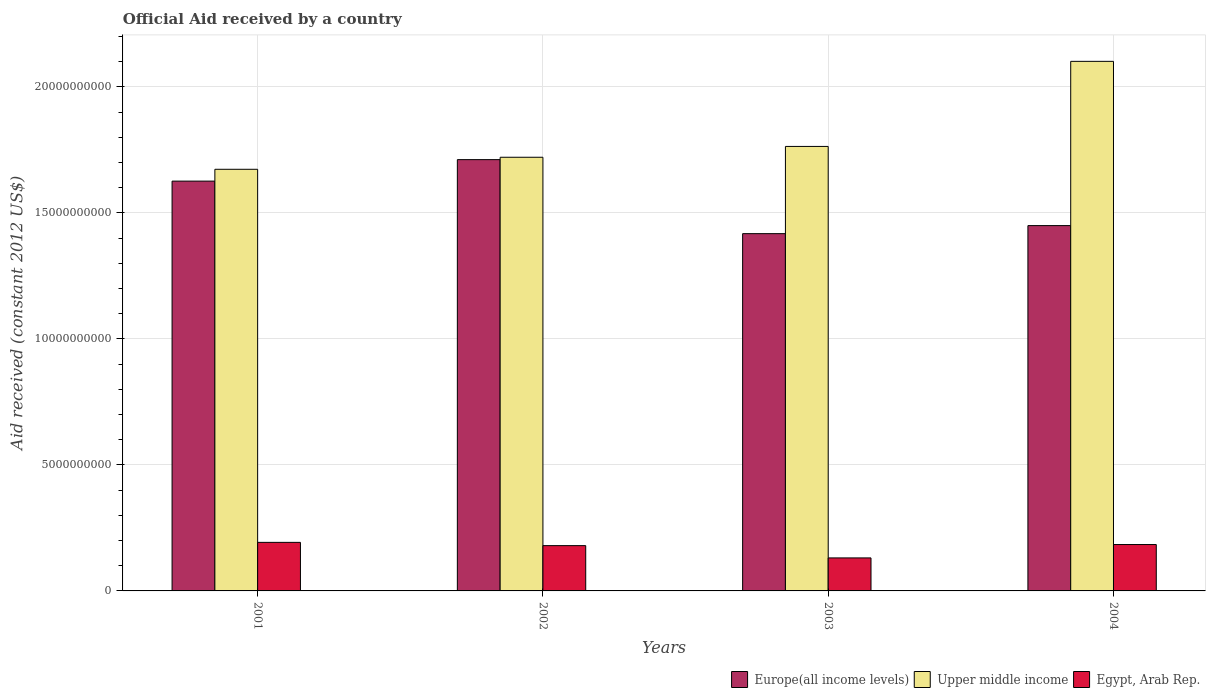How many different coloured bars are there?
Your answer should be compact. 3. Are the number of bars on each tick of the X-axis equal?
Provide a succinct answer. Yes. How many bars are there on the 4th tick from the right?
Your response must be concise. 3. What is the label of the 2nd group of bars from the left?
Make the answer very short. 2002. What is the net official aid received in Europe(all income levels) in 2003?
Make the answer very short. 1.42e+1. Across all years, what is the maximum net official aid received in Europe(all income levels)?
Offer a very short reply. 1.71e+1. Across all years, what is the minimum net official aid received in Egypt, Arab Rep.?
Make the answer very short. 1.31e+09. In which year was the net official aid received in Europe(all income levels) maximum?
Your response must be concise. 2002. What is the total net official aid received in Egypt, Arab Rep. in the graph?
Give a very brief answer. 6.87e+09. What is the difference between the net official aid received in Upper middle income in 2001 and that in 2004?
Provide a succinct answer. -4.28e+09. What is the difference between the net official aid received in Upper middle income in 2003 and the net official aid received in Egypt, Arab Rep. in 2002?
Make the answer very short. 1.58e+1. What is the average net official aid received in Egypt, Arab Rep. per year?
Offer a very short reply. 1.72e+09. In the year 2001, what is the difference between the net official aid received in Europe(all income levels) and net official aid received in Upper middle income?
Your response must be concise. -4.69e+08. In how many years, is the net official aid received in Upper middle income greater than 17000000000 US$?
Your answer should be very brief. 3. What is the ratio of the net official aid received in Upper middle income in 2001 to that in 2004?
Your answer should be compact. 0.8. Is the difference between the net official aid received in Europe(all income levels) in 2001 and 2004 greater than the difference between the net official aid received in Upper middle income in 2001 and 2004?
Make the answer very short. Yes. What is the difference between the highest and the second highest net official aid received in Europe(all income levels)?
Your response must be concise. 8.52e+08. What is the difference between the highest and the lowest net official aid received in Europe(all income levels)?
Offer a terse response. 2.94e+09. In how many years, is the net official aid received in Egypt, Arab Rep. greater than the average net official aid received in Egypt, Arab Rep. taken over all years?
Ensure brevity in your answer.  3. Is the sum of the net official aid received in Egypt, Arab Rep. in 2002 and 2003 greater than the maximum net official aid received in Upper middle income across all years?
Keep it short and to the point. No. What does the 2nd bar from the left in 2001 represents?
Your answer should be very brief. Upper middle income. What does the 2nd bar from the right in 2002 represents?
Your answer should be compact. Upper middle income. How many bars are there?
Your answer should be compact. 12. How many years are there in the graph?
Offer a very short reply. 4. What is the difference between two consecutive major ticks on the Y-axis?
Make the answer very short. 5.00e+09. Does the graph contain any zero values?
Your answer should be very brief. No. Where does the legend appear in the graph?
Ensure brevity in your answer.  Bottom right. How many legend labels are there?
Your answer should be compact. 3. How are the legend labels stacked?
Your answer should be very brief. Horizontal. What is the title of the graph?
Make the answer very short. Official Aid received by a country. Does "South Africa" appear as one of the legend labels in the graph?
Give a very brief answer. No. What is the label or title of the X-axis?
Ensure brevity in your answer.  Years. What is the label or title of the Y-axis?
Offer a terse response. Aid received (constant 2012 US$). What is the Aid received (constant 2012 US$) of Europe(all income levels) in 2001?
Your answer should be very brief. 1.63e+1. What is the Aid received (constant 2012 US$) of Upper middle income in 2001?
Offer a very short reply. 1.67e+1. What is the Aid received (constant 2012 US$) in Egypt, Arab Rep. in 2001?
Your response must be concise. 1.93e+09. What is the Aid received (constant 2012 US$) in Europe(all income levels) in 2002?
Ensure brevity in your answer.  1.71e+1. What is the Aid received (constant 2012 US$) in Upper middle income in 2002?
Provide a succinct answer. 1.72e+1. What is the Aid received (constant 2012 US$) in Egypt, Arab Rep. in 2002?
Your answer should be compact. 1.80e+09. What is the Aid received (constant 2012 US$) in Europe(all income levels) in 2003?
Give a very brief answer. 1.42e+1. What is the Aid received (constant 2012 US$) in Upper middle income in 2003?
Your answer should be compact. 1.76e+1. What is the Aid received (constant 2012 US$) of Egypt, Arab Rep. in 2003?
Your answer should be very brief. 1.31e+09. What is the Aid received (constant 2012 US$) of Europe(all income levels) in 2004?
Your answer should be very brief. 1.45e+1. What is the Aid received (constant 2012 US$) in Upper middle income in 2004?
Keep it short and to the point. 2.10e+1. What is the Aid received (constant 2012 US$) in Egypt, Arab Rep. in 2004?
Your answer should be very brief. 1.84e+09. Across all years, what is the maximum Aid received (constant 2012 US$) in Europe(all income levels)?
Offer a very short reply. 1.71e+1. Across all years, what is the maximum Aid received (constant 2012 US$) of Upper middle income?
Your response must be concise. 2.10e+1. Across all years, what is the maximum Aid received (constant 2012 US$) in Egypt, Arab Rep.?
Offer a terse response. 1.93e+09. Across all years, what is the minimum Aid received (constant 2012 US$) of Europe(all income levels)?
Your response must be concise. 1.42e+1. Across all years, what is the minimum Aid received (constant 2012 US$) in Upper middle income?
Offer a very short reply. 1.67e+1. Across all years, what is the minimum Aid received (constant 2012 US$) of Egypt, Arab Rep.?
Your response must be concise. 1.31e+09. What is the total Aid received (constant 2012 US$) in Europe(all income levels) in the graph?
Your answer should be very brief. 6.21e+1. What is the total Aid received (constant 2012 US$) in Upper middle income in the graph?
Give a very brief answer. 7.26e+1. What is the total Aid received (constant 2012 US$) of Egypt, Arab Rep. in the graph?
Make the answer very short. 6.87e+09. What is the difference between the Aid received (constant 2012 US$) in Europe(all income levels) in 2001 and that in 2002?
Offer a terse response. -8.52e+08. What is the difference between the Aid received (constant 2012 US$) in Upper middle income in 2001 and that in 2002?
Provide a short and direct response. -4.77e+08. What is the difference between the Aid received (constant 2012 US$) of Egypt, Arab Rep. in 2001 and that in 2002?
Make the answer very short. 1.29e+08. What is the difference between the Aid received (constant 2012 US$) in Europe(all income levels) in 2001 and that in 2003?
Your answer should be compact. 2.08e+09. What is the difference between the Aid received (constant 2012 US$) of Upper middle income in 2001 and that in 2003?
Your answer should be compact. -9.07e+08. What is the difference between the Aid received (constant 2012 US$) in Egypt, Arab Rep. in 2001 and that in 2003?
Keep it short and to the point. 6.17e+08. What is the difference between the Aid received (constant 2012 US$) in Europe(all income levels) in 2001 and that in 2004?
Offer a very short reply. 1.77e+09. What is the difference between the Aid received (constant 2012 US$) of Upper middle income in 2001 and that in 2004?
Your answer should be very brief. -4.28e+09. What is the difference between the Aid received (constant 2012 US$) in Egypt, Arab Rep. in 2001 and that in 2004?
Offer a very short reply. 8.60e+07. What is the difference between the Aid received (constant 2012 US$) in Europe(all income levels) in 2002 and that in 2003?
Your response must be concise. 2.94e+09. What is the difference between the Aid received (constant 2012 US$) of Upper middle income in 2002 and that in 2003?
Make the answer very short. -4.30e+08. What is the difference between the Aid received (constant 2012 US$) of Egypt, Arab Rep. in 2002 and that in 2003?
Offer a very short reply. 4.87e+08. What is the difference between the Aid received (constant 2012 US$) in Europe(all income levels) in 2002 and that in 2004?
Ensure brevity in your answer.  2.62e+09. What is the difference between the Aid received (constant 2012 US$) in Upper middle income in 2002 and that in 2004?
Ensure brevity in your answer.  -3.81e+09. What is the difference between the Aid received (constant 2012 US$) of Egypt, Arab Rep. in 2002 and that in 2004?
Ensure brevity in your answer.  -4.33e+07. What is the difference between the Aid received (constant 2012 US$) in Europe(all income levels) in 2003 and that in 2004?
Your answer should be very brief. -3.20e+08. What is the difference between the Aid received (constant 2012 US$) of Upper middle income in 2003 and that in 2004?
Offer a terse response. -3.38e+09. What is the difference between the Aid received (constant 2012 US$) of Egypt, Arab Rep. in 2003 and that in 2004?
Offer a terse response. -5.31e+08. What is the difference between the Aid received (constant 2012 US$) in Europe(all income levels) in 2001 and the Aid received (constant 2012 US$) in Upper middle income in 2002?
Make the answer very short. -9.46e+08. What is the difference between the Aid received (constant 2012 US$) of Europe(all income levels) in 2001 and the Aid received (constant 2012 US$) of Egypt, Arab Rep. in 2002?
Your answer should be compact. 1.45e+1. What is the difference between the Aid received (constant 2012 US$) in Upper middle income in 2001 and the Aid received (constant 2012 US$) in Egypt, Arab Rep. in 2002?
Your response must be concise. 1.49e+1. What is the difference between the Aid received (constant 2012 US$) in Europe(all income levels) in 2001 and the Aid received (constant 2012 US$) in Upper middle income in 2003?
Make the answer very short. -1.38e+09. What is the difference between the Aid received (constant 2012 US$) in Europe(all income levels) in 2001 and the Aid received (constant 2012 US$) in Egypt, Arab Rep. in 2003?
Keep it short and to the point. 1.50e+1. What is the difference between the Aid received (constant 2012 US$) in Upper middle income in 2001 and the Aid received (constant 2012 US$) in Egypt, Arab Rep. in 2003?
Your answer should be compact. 1.54e+1. What is the difference between the Aid received (constant 2012 US$) of Europe(all income levels) in 2001 and the Aid received (constant 2012 US$) of Upper middle income in 2004?
Keep it short and to the point. -4.75e+09. What is the difference between the Aid received (constant 2012 US$) in Europe(all income levels) in 2001 and the Aid received (constant 2012 US$) in Egypt, Arab Rep. in 2004?
Your answer should be very brief. 1.44e+1. What is the difference between the Aid received (constant 2012 US$) in Upper middle income in 2001 and the Aid received (constant 2012 US$) in Egypt, Arab Rep. in 2004?
Offer a terse response. 1.49e+1. What is the difference between the Aid received (constant 2012 US$) of Europe(all income levels) in 2002 and the Aid received (constant 2012 US$) of Upper middle income in 2003?
Your answer should be compact. -5.24e+08. What is the difference between the Aid received (constant 2012 US$) of Europe(all income levels) in 2002 and the Aid received (constant 2012 US$) of Egypt, Arab Rep. in 2003?
Ensure brevity in your answer.  1.58e+1. What is the difference between the Aid received (constant 2012 US$) in Upper middle income in 2002 and the Aid received (constant 2012 US$) in Egypt, Arab Rep. in 2003?
Give a very brief answer. 1.59e+1. What is the difference between the Aid received (constant 2012 US$) of Europe(all income levels) in 2002 and the Aid received (constant 2012 US$) of Upper middle income in 2004?
Give a very brief answer. -3.90e+09. What is the difference between the Aid received (constant 2012 US$) in Europe(all income levels) in 2002 and the Aid received (constant 2012 US$) in Egypt, Arab Rep. in 2004?
Provide a succinct answer. 1.53e+1. What is the difference between the Aid received (constant 2012 US$) in Upper middle income in 2002 and the Aid received (constant 2012 US$) in Egypt, Arab Rep. in 2004?
Offer a very short reply. 1.54e+1. What is the difference between the Aid received (constant 2012 US$) in Europe(all income levels) in 2003 and the Aid received (constant 2012 US$) in Upper middle income in 2004?
Make the answer very short. -6.84e+09. What is the difference between the Aid received (constant 2012 US$) in Europe(all income levels) in 2003 and the Aid received (constant 2012 US$) in Egypt, Arab Rep. in 2004?
Keep it short and to the point. 1.23e+1. What is the difference between the Aid received (constant 2012 US$) of Upper middle income in 2003 and the Aid received (constant 2012 US$) of Egypt, Arab Rep. in 2004?
Offer a very short reply. 1.58e+1. What is the average Aid received (constant 2012 US$) in Europe(all income levels) per year?
Keep it short and to the point. 1.55e+1. What is the average Aid received (constant 2012 US$) of Upper middle income per year?
Ensure brevity in your answer.  1.81e+1. What is the average Aid received (constant 2012 US$) of Egypt, Arab Rep. per year?
Provide a short and direct response. 1.72e+09. In the year 2001, what is the difference between the Aid received (constant 2012 US$) in Europe(all income levels) and Aid received (constant 2012 US$) in Upper middle income?
Offer a terse response. -4.69e+08. In the year 2001, what is the difference between the Aid received (constant 2012 US$) of Europe(all income levels) and Aid received (constant 2012 US$) of Egypt, Arab Rep.?
Provide a succinct answer. 1.43e+1. In the year 2001, what is the difference between the Aid received (constant 2012 US$) in Upper middle income and Aid received (constant 2012 US$) in Egypt, Arab Rep.?
Your response must be concise. 1.48e+1. In the year 2002, what is the difference between the Aid received (constant 2012 US$) in Europe(all income levels) and Aid received (constant 2012 US$) in Upper middle income?
Your response must be concise. -9.41e+07. In the year 2002, what is the difference between the Aid received (constant 2012 US$) in Europe(all income levels) and Aid received (constant 2012 US$) in Egypt, Arab Rep.?
Give a very brief answer. 1.53e+1. In the year 2002, what is the difference between the Aid received (constant 2012 US$) in Upper middle income and Aid received (constant 2012 US$) in Egypt, Arab Rep.?
Give a very brief answer. 1.54e+1. In the year 2003, what is the difference between the Aid received (constant 2012 US$) in Europe(all income levels) and Aid received (constant 2012 US$) in Upper middle income?
Your answer should be very brief. -3.46e+09. In the year 2003, what is the difference between the Aid received (constant 2012 US$) in Europe(all income levels) and Aid received (constant 2012 US$) in Egypt, Arab Rep.?
Provide a short and direct response. 1.29e+1. In the year 2003, what is the difference between the Aid received (constant 2012 US$) in Upper middle income and Aid received (constant 2012 US$) in Egypt, Arab Rep.?
Offer a very short reply. 1.63e+1. In the year 2004, what is the difference between the Aid received (constant 2012 US$) of Europe(all income levels) and Aid received (constant 2012 US$) of Upper middle income?
Keep it short and to the point. -6.52e+09. In the year 2004, what is the difference between the Aid received (constant 2012 US$) of Europe(all income levels) and Aid received (constant 2012 US$) of Egypt, Arab Rep.?
Your response must be concise. 1.27e+1. In the year 2004, what is the difference between the Aid received (constant 2012 US$) in Upper middle income and Aid received (constant 2012 US$) in Egypt, Arab Rep.?
Offer a very short reply. 1.92e+1. What is the ratio of the Aid received (constant 2012 US$) in Europe(all income levels) in 2001 to that in 2002?
Provide a succinct answer. 0.95. What is the ratio of the Aid received (constant 2012 US$) in Upper middle income in 2001 to that in 2002?
Ensure brevity in your answer.  0.97. What is the ratio of the Aid received (constant 2012 US$) in Egypt, Arab Rep. in 2001 to that in 2002?
Provide a short and direct response. 1.07. What is the ratio of the Aid received (constant 2012 US$) in Europe(all income levels) in 2001 to that in 2003?
Your response must be concise. 1.15. What is the ratio of the Aid received (constant 2012 US$) in Upper middle income in 2001 to that in 2003?
Give a very brief answer. 0.95. What is the ratio of the Aid received (constant 2012 US$) of Egypt, Arab Rep. in 2001 to that in 2003?
Your response must be concise. 1.47. What is the ratio of the Aid received (constant 2012 US$) of Europe(all income levels) in 2001 to that in 2004?
Make the answer very short. 1.12. What is the ratio of the Aid received (constant 2012 US$) in Upper middle income in 2001 to that in 2004?
Make the answer very short. 0.8. What is the ratio of the Aid received (constant 2012 US$) in Egypt, Arab Rep. in 2001 to that in 2004?
Your answer should be very brief. 1.05. What is the ratio of the Aid received (constant 2012 US$) of Europe(all income levels) in 2002 to that in 2003?
Give a very brief answer. 1.21. What is the ratio of the Aid received (constant 2012 US$) in Upper middle income in 2002 to that in 2003?
Offer a terse response. 0.98. What is the ratio of the Aid received (constant 2012 US$) of Egypt, Arab Rep. in 2002 to that in 2003?
Ensure brevity in your answer.  1.37. What is the ratio of the Aid received (constant 2012 US$) of Europe(all income levels) in 2002 to that in 2004?
Offer a very short reply. 1.18. What is the ratio of the Aid received (constant 2012 US$) in Upper middle income in 2002 to that in 2004?
Offer a very short reply. 0.82. What is the ratio of the Aid received (constant 2012 US$) in Egypt, Arab Rep. in 2002 to that in 2004?
Your answer should be compact. 0.98. What is the ratio of the Aid received (constant 2012 US$) of Europe(all income levels) in 2003 to that in 2004?
Your answer should be very brief. 0.98. What is the ratio of the Aid received (constant 2012 US$) in Upper middle income in 2003 to that in 2004?
Offer a very short reply. 0.84. What is the ratio of the Aid received (constant 2012 US$) in Egypt, Arab Rep. in 2003 to that in 2004?
Give a very brief answer. 0.71. What is the difference between the highest and the second highest Aid received (constant 2012 US$) of Europe(all income levels)?
Keep it short and to the point. 8.52e+08. What is the difference between the highest and the second highest Aid received (constant 2012 US$) in Upper middle income?
Your answer should be very brief. 3.38e+09. What is the difference between the highest and the second highest Aid received (constant 2012 US$) of Egypt, Arab Rep.?
Give a very brief answer. 8.60e+07. What is the difference between the highest and the lowest Aid received (constant 2012 US$) in Europe(all income levels)?
Your answer should be very brief. 2.94e+09. What is the difference between the highest and the lowest Aid received (constant 2012 US$) in Upper middle income?
Ensure brevity in your answer.  4.28e+09. What is the difference between the highest and the lowest Aid received (constant 2012 US$) in Egypt, Arab Rep.?
Your answer should be very brief. 6.17e+08. 